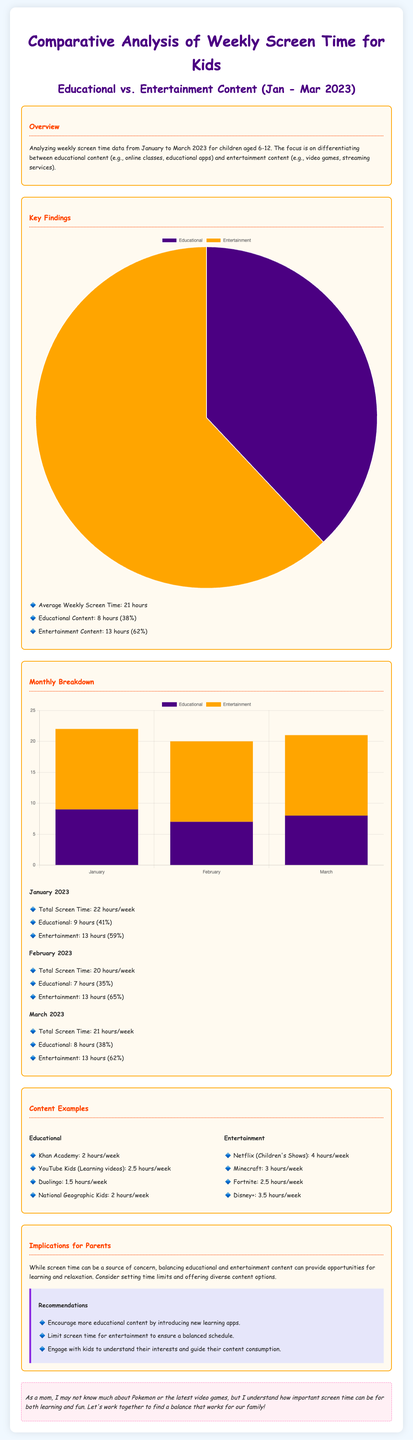What is the average weekly screen time? The average weekly screen time is stated directly in the document.
Answer: 21 hours How many hours of educational content were consumed on average? The document specifies the amount of educational content in hours.
Answer: 8 hours What percentage of screen time was dedicated to entertainment content? The document shows the percentage of screen time dedicated to entertainment.
Answer: 62% What was the total screen time in January 2023? The document provides the specific total screen time for January.
Answer: 22 hours/week In which month did educational screen time drop to 7 hours? The document shows the monthly breakdown of screen times for educational content.
Answer: February 2023 Which educational app had 2 hours of usage per week? The document lists the educational content and their respective hours.
Answer: Khan Academy What was the total screen time for kids in March 2023? The specific total for March is directly mentioned in the document.
Answer: 21 hours/week What is the title of this statistical infographic? The title is clearly mentioned at the beginning of the document.
Answer: Comparative Analysis of Weekly Screen Time for Kids Which streaming service was listed with the highest consumption in entertainment content? The document provides a list and consumption levels of different entertainment options.
Answer: Netflix (Children's Shows) 